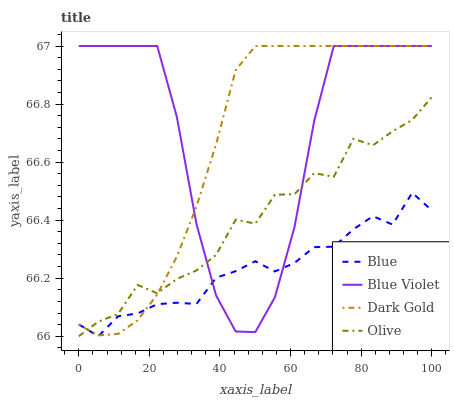Does Blue have the minimum area under the curve?
Answer yes or no. Yes. Does Blue Violet have the maximum area under the curve?
Answer yes or no. Yes. Does Olive have the minimum area under the curve?
Answer yes or no. No. Does Olive have the maximum area under the curve?
Answer yes or no. No. Is Dark Gold the smoothest?
Answer yes or no. Yes. Is Blue Violet the roughest?
Answer yes or no. Yes. Is Olive the smoothest?
Answer yes or no. No. Is Olive the roughest?
Answer yes or no. No. Does Blue have the lowest value?
Answer yes or no. Yes. Does Blue Violet have the lowest value?
Answer yes or no. No. Does Dark Gold have the highest value?
Answer yes or no. Yes. Does Olive have the highest value?
Answer yes or no. No. Does Dark Gold intersect Olive?
Answer yes or no. Yes. Is Dark Gold less than Olive?
Answer yes or no. No. Is Dark Gold greater than Olive?
Answer yes or no. No. 